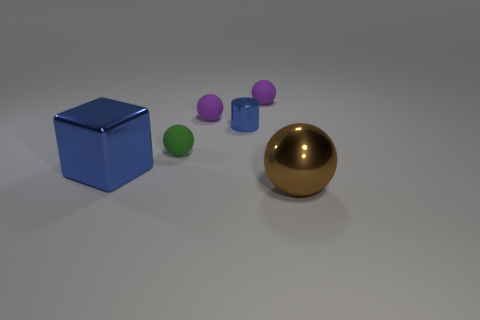Add 3 big metallic cubes. How many objects exist? 9 Subtract all spheres. How many objects are left? 2 Subtract all large blue metallic cubes. Subtract all tiny blue metal cylinders. How many objects are left? 4 Add 4 shiny blocks. How many shiny blocks are left? 5 Add 3 large yellow metallic cubes. How many large yellow metallic cubes exist? 3 Subtract 1 brown balls. How many objects are left? 5 